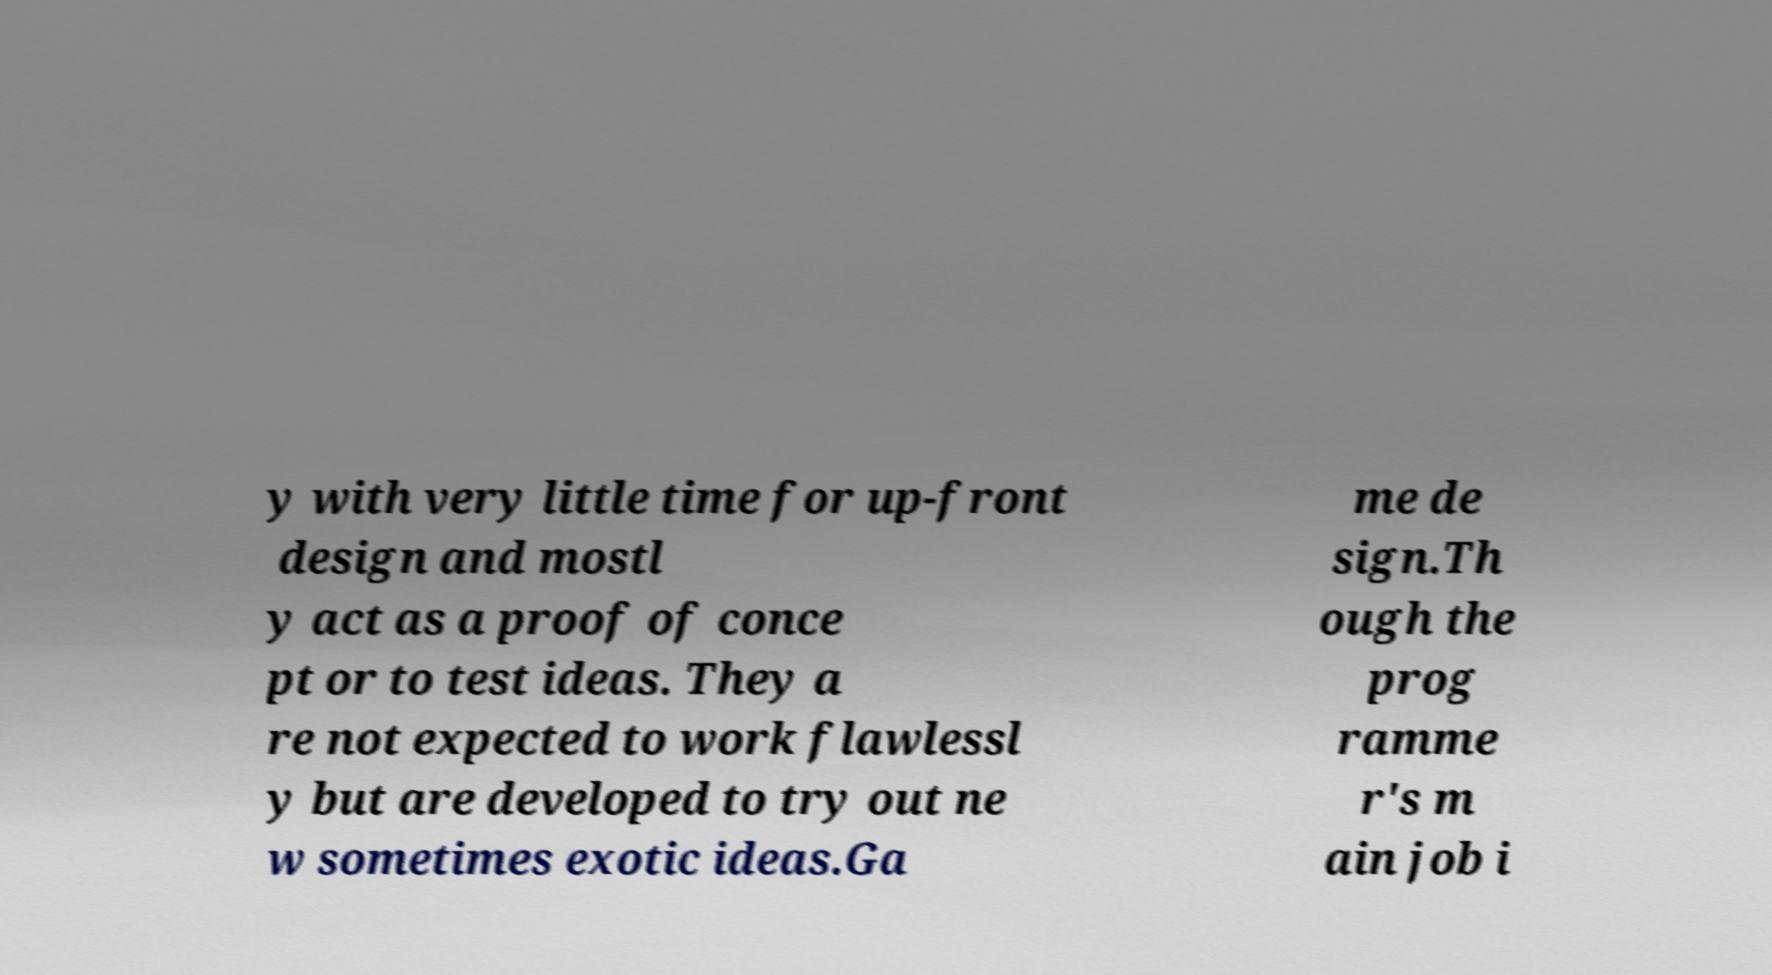What messages or text are displayed in this image? I need them in a readable, typed format. y with very little time for up-front design and mostl y act as a proof of conce pt or to test ideas. They a re not expected to work flawlessl y but are developed to try out ne w sometimes exotic ideas.Ga me de sign.Th ough the prog ramme r's m ain job i 